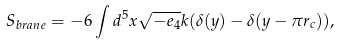Convert formula to latex. <formula><loc_0><loc_0><loc_500><loc_500>S _ { b r a n e } = - 6 \int d ^ { 5 } x \sqrt { - e _ { 4 } } k ( \delta ( y ) - \delta ( y - \pi r _ { c } ) ) ,</formula> 